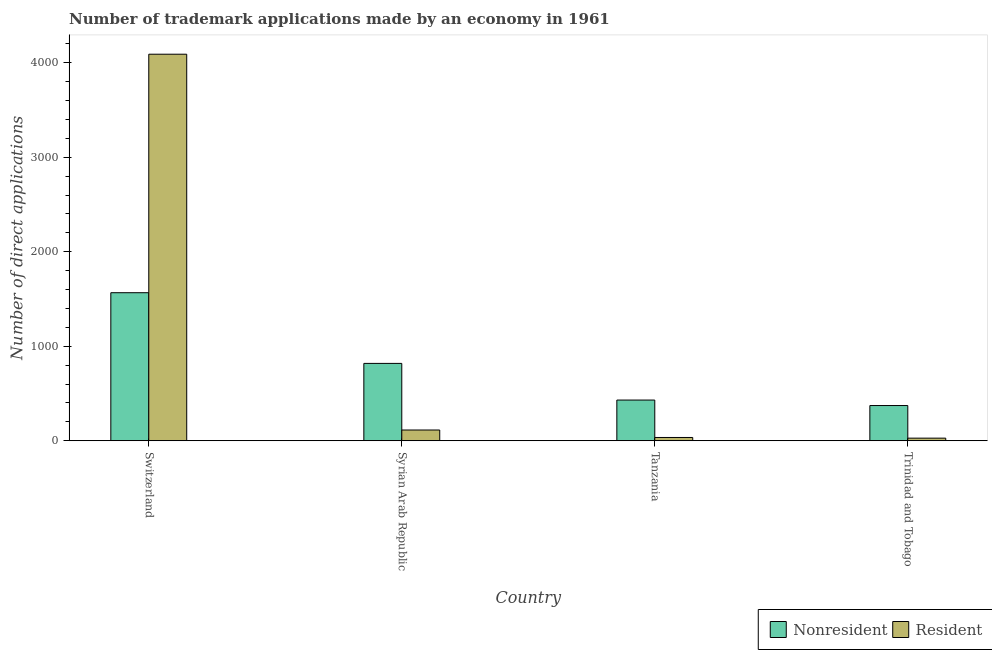How many different coloured bars are there?
Give a very brief answer. 2. How many groups of bars are there?
Offer a very short reply. 4. How many bars are there on the 4th tick from the left?
Ensure brevity in your answer.  2. How many bars are there on the 4th tick from the right?
Your answer should be very brief. 2. What is the label of the 4th group of bars from the left?
Provide a succinct answer. Trinidad and Tobago. In how many cases, is the number of bars for a given country not equal to the number of legend labels?
Offer a terse response. 0. What is the number of trademark applications made by residents in Syrian Arab Republic?
Offer a very short reply. 114. Across all countries, what is the maximum number of trademark applications made by residents?
Provide a short and direct response. 4091. Across all countries, what is the minimum number of trademark applications made by non residents?
Provide a succinct answer. 373. In which country was the number of trademark applications made by non residents maximum?
Provide a short and direct response. Switzerland. In which country was the number of trademark applications made by residents minimum?
Make the answer very short. Trinidad and Tobago. What is the total number of trademark applications made by non residents in the graph?
Your response must be concise. 3190. What is the difference between the number of trademark applications made by non residents in Syrian Arab Republic and that in Trinidad and Tobago?
Offer a terse response. 446. What is the difference between the number of trademark applications made by residents in Syrian Arab Republic and the number of trademark applications made by non residents in Trinidad and Tobago?
Keep it short and to the point. -259. What is the average number of trademark applications made by residents per country?
Ensure brevity in your answer.  1067. What is the difference between the number of trademark applications made by residents and number of trademark applications made by non residents in Trinidad and Tobago?
Provide a succinct answer. -345. What is the ratio of the number of trademark applications made by non residents in Switzerland to that in Tanzania?
Ensure brevity in your answer.  3.64. What is the difference between the highest and the second highest number of trademark applications made by residents?
Provide a short and direct response. 3977. What is the difference between the highest and the lowest number of trademark applications made by non residents?
Your answer should be very brief. 1194. Is the sum of the number of trademark applications made by non residents in Syrian Arab Republic and Trinidad and Tobago greater than the maximum number of trademark applications made by residents across all countries?
Provide a short and direct response. No. What does the 1st bar from the left in Trinidad and Tobago represents?
Your response must be concise. Nonresident. What does the 2nd bar from the right in Syrian Arab Republic represents?
Give a very brief answer. Nonresident. Does the graph contain any zero values?
Offer a very short reply. No. Does the graph contain grids?
Your response must be concise. No. How many legend labels are there?
Your response must be concise. 2. What is the title of the graph?
Give a very brief answer. Number of trademark applications made by an economy in 1961. Does "Highest 20% of population" appear as one of the legend labels in the graph?
Provide a short and direct response. No. What is the label or title of the Y-axis?
Provide a succinct answer. Number of direct applications. What is the Number of direct applications in Nonresident in Switzerland?
Keep it short and to the point. 1567. What is the Number of direct applications of Resident in Switzerland?
Give a very brief answer. 4091. What is the Number of direct applications in Nonresident in Syrian Arab Republic?
Your answer should be very brief. 819. What is the Number of direct applications in Resident in Syrian Arab Republic?
Offer a very short reply. 114. What is the Number of direct applications in Nonresident in Tanzania?
Provide a succinct answer. 431. What is the Number of direct applications of Resident in Tanzania?
Provide a succinct answer. 35. What is the Number of direct applications of Nonresident in Trinidad and Tobago?
Your answer should be compact. 373. Across all countries, what is the maximum Number of direct applications of Nonresident?
Give a very brief answer. 1567. Across all countries, what is the maximum Number of direct applications of Resident?
Your answer should be compact. 4091. Across all countries, what is the minimum Number of direct applications of Nonresident?
Your response must be concise. 373. Across all countries, what is the minimum Number of direct applications in Resident?
Provide a succinct answer. 28. What is the total Number of direct applications of Nonresident in the graph?
Your response must be concise. 3190. What is the total Number of direct applications in Resident in the graph?
Give a very brief answer. 4268. What is the difference between the Number of direct applications in Nonresident in Switzerland and that in Syrian Arab Republic?
Offer a very short reply. 748. What is the difference between the Number of direct applications in Resident in Switzerland and that in Syrian Arab Republic?
Your response must be concise. 3977. What is the difference between the Number of direct applications in Nonresident in Switzerland and that in Tanzania?
Your answer should be compact. 1136. What is the difference between the Number of direct applications of Resident in Switzerland and that in Tanzania?
Your answer should be compact. 4056. What is the difference between the Number of direct applications of Nonresident in Switzerland and that in Trinidad and Tobago?
Your answer should be very brief. 1194. What is the difference between the Number of direct applications of Resident in Switzerland and that in Trinidad and Tobago?
Your answer should be very brief. 4063. What is the difference between the Number of direct applications of Nonresident in Syrian Arab Republic and that in Tanzania?
Your answer should be very brief. 388. What is the difference between the Number of direct applications of Resident in Syrian Arab Republic and that in Tanzania?
Offer a very short reply. 79. What is the difference between the Number of direct applications in Nonresident in Syrian Arab Republic and that in Trinidad and Tobago?
Provide a succinct answer. 446. What is the difference between the Number of direct applications in Nonresident in Tanzania and that in Trinidad and Tobago?
Provide a short and direct response. 58. What is the difference between the Number of direct applications of Nonresident in Switzerland and the Number of direct applications of Resident in Syrian Arab Republic?
Your answer should be very brief. 1453. What is the difference between the Number of direct applications in Nonresident in Switzerland and the Number of direct applications in Resident in Tanzania?
Your response must be concise. 1532. What is the difference between the Number of direct applications in Nonresident in Switzerland and the Number of direct applications in Resident in Trinidad and Tobago?
Your answer should be very brief. 1539. What is the difference between the Number of direct applications of Nonresident in Syrian Arab Republic and the Number of direct applications of Resident in Tanzania?
Offer a terse response. 784. What is the difference between the Number of direct applications of Nonresident in Syrian Arab Republic and the Number of direct applications of Resident in Trinidad and Tobago?
Provide a short and direct response. 791. What is the difference between the Number of direct applications in Nonresident in Tanzania and the Number of direct applications in Resident in Trinidad and Tobago?
Your answer should be very brief. 403. What is the average Number of direct applications of Nonresident per country?
Provide a succinct answer. 797.5. What is the average Number of direct applications in Resident per country?
Offer a very short reply. 1067. What is the difference between the Number of direct applications in Nonresident and Number of direct applications in Resident in Switzerland?
Your answer should be compact. -2524. What is the difference between the Number of direct applications in Nonresident and Number of direct applications in Resident in Syrian Arab Republic?
Provide a succinct answer. 705. What is the difference between the Number of direct applications of Nonresident and Number of direct applications of Resident in Tanzania?
Offer a very short reply. 396. What is the difference between the Number of direct applications in Nonresident and Number of direct applications in Resident in Trinidad and Tobago?
Give a very brief answer. 345. What is the ratio of the Number of direct applications of Nonresident in Switzerland to that in Syrian Arab Republic?
Make the answer very short. 1.91. What is the ratio of the Number of direct applications of Resident in Switzerland to that in Syrian Arab Republic?
Provide a short and direct response. 35.89. What is the ratio of the Number of direct applications of Nonresident in Switzerland to that in Tanzania?
Offer a terse response. 3.64. What is the ratio of the Number of direct applications of Resident in Switzerland to that in Tanzania?
Your response must be concise. 116.89. What is the ratio of the Number of direct applications in Nonresident in Switzerland to that in Trinidad and Tobago?
Offer a very short reply. 4.2. What is the ratio of the Number of direct applications of Resident in Switzerland to that in Trinidad and Tobago?
Offer a terse response. 146.11. What is the ratio of the Number of direct applications in Nonresident in Syrian Arab Republic to that in Tanzania?
Provide a succinct answer. 1.9. What is the ratio of the Number of direct applications in Resident in Syrian Arab Republic to that in Tanzania?
Offer a terse response. 3.26. What is the ratio of the Number of direct applications of Nonresident in Syrian Arab Republic to that in Trinidad and Tobago?
Provide a succinct answer. 2.2. What is the ratio of the Number of direct applications of Resident in Syrian Arab Republic to that in Trinidad and Tobago?
Make the answer very short. 4.07. What is the ratio of the Number of direct applications of Nonresident in Tanzania to that in Trinidad and Tobago?
Make the answer very short. 1.16. What is the difference between the highest and the second highest Number of direct applications of Nonresident?
Offer a terse response. 748. What is the difference between the highest and the second highest Number of direct applications in Resident?
Your answer should be compact. 3977. What is the difference between the highest and the lowest Number of direct applications of Nonresident?
Your response must be concise. 1194. What is the difference between the highest and the lowest Number of direct applications of Resident?
Your answer should be very brief. 4063. 